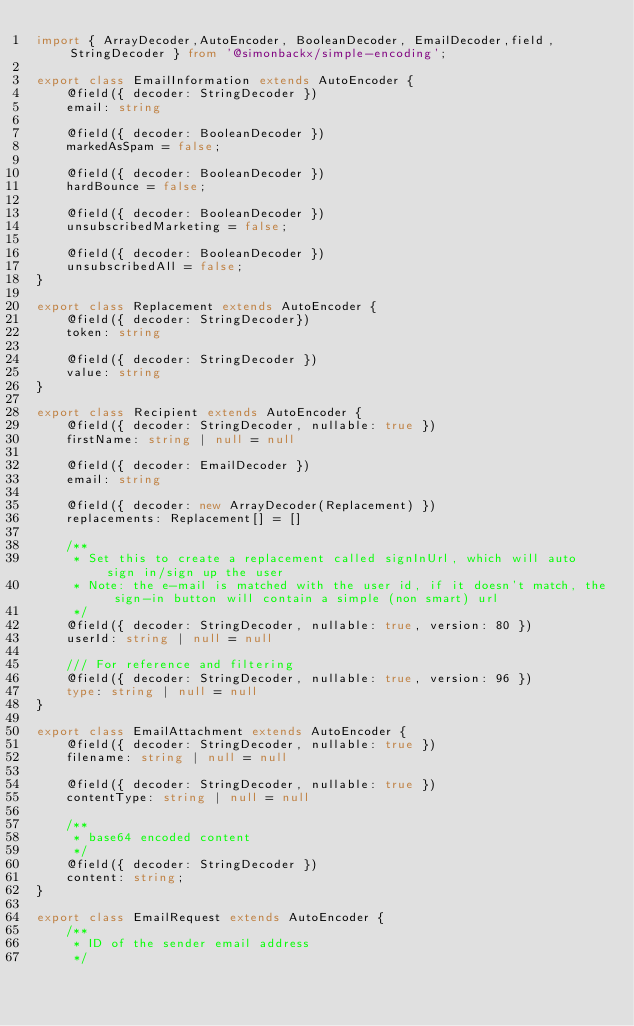<code> <loc_0><loc_0><loc_500><loc_500><_TypeScript_>import { ArrayDecoder,AutoEncoder, BooleanDecoder, EmailDecoder,field, StringDecoder } from '@simonbackx/simple-encoding';

export class EmailInformation extends AutoEncoder {
    @field({ decoder: StringDecoder })
    email: string

    @field({ decoder: BooleanDecoder })
    markedAsSpam = false;

    @field({ decoder: BooleanDecoder })
    hardBounce = false;

    @field({ decoder: BooleanDecoder })
    unsubscribedMarketing = false;

    @field({ decoder: BooleanDecoder })
    unsubscribedAll = false;
}

export class Replacement extends AutoEncoder {
    @field({ decoder: StringDecoder})
    token: string 

    @field({ decoder: StringDecoder })
    value: string 
}

export class Recipient extends AutoEncoder {
    @field({ decoder: StringDecoder, nullable: true })
    firstName: string | null = null

    @field({ decoder: EmailDecoder })
    email: string

    @field({ decoder: new ArrayDecoder(Replacement) })
    replacements: Replacement[] = []

    /**
     * Set this to create a replacement called signInUrl, which will auto sign in/sign up the user
     * Note: the e-mail is matched with the user id, if it doesn't match, the sign-in button will contain a simple (non smart) url
     */
    @field({ decoder: StringDecoder, nullable: true, version: 80 })
    userId: string | null = null

    /// For reference and filtering
    @field({ decoder: StringDecoder, nullable: true, version: 96 })
    type: string | null = null
}

export class EmailAttachment extends AutoEncoder {
    @field({ decoder: StringDecoder, nullable: true })
    filename: string | null = null

    @field({ decoder: StringDecoder, nullable: true })
    contentType: string | null = null

    /**
     * base64 encoded content
     */
    @field({ decoder: StringDecoder })
    content: string;
}

export class EmailRequest extends AutoEncoder {
    /**
     * ID of the sender email address
     */</code> 